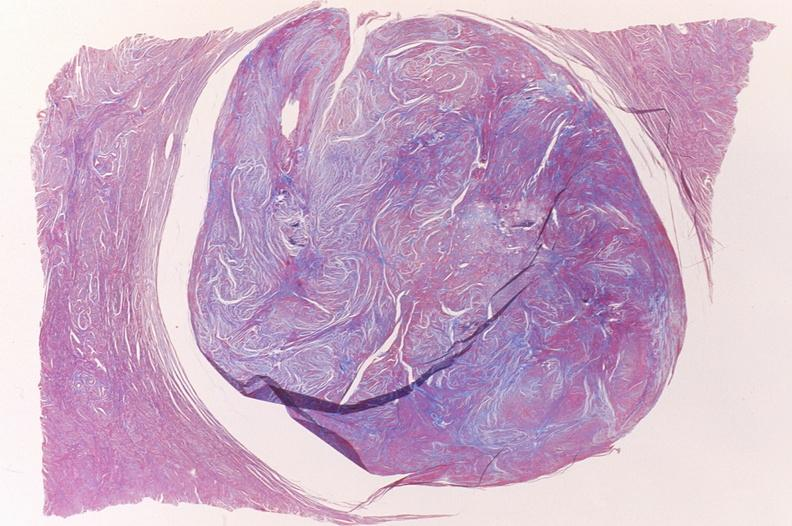s female reproductive present?
Answer the question using a single word or phrase. Yes 